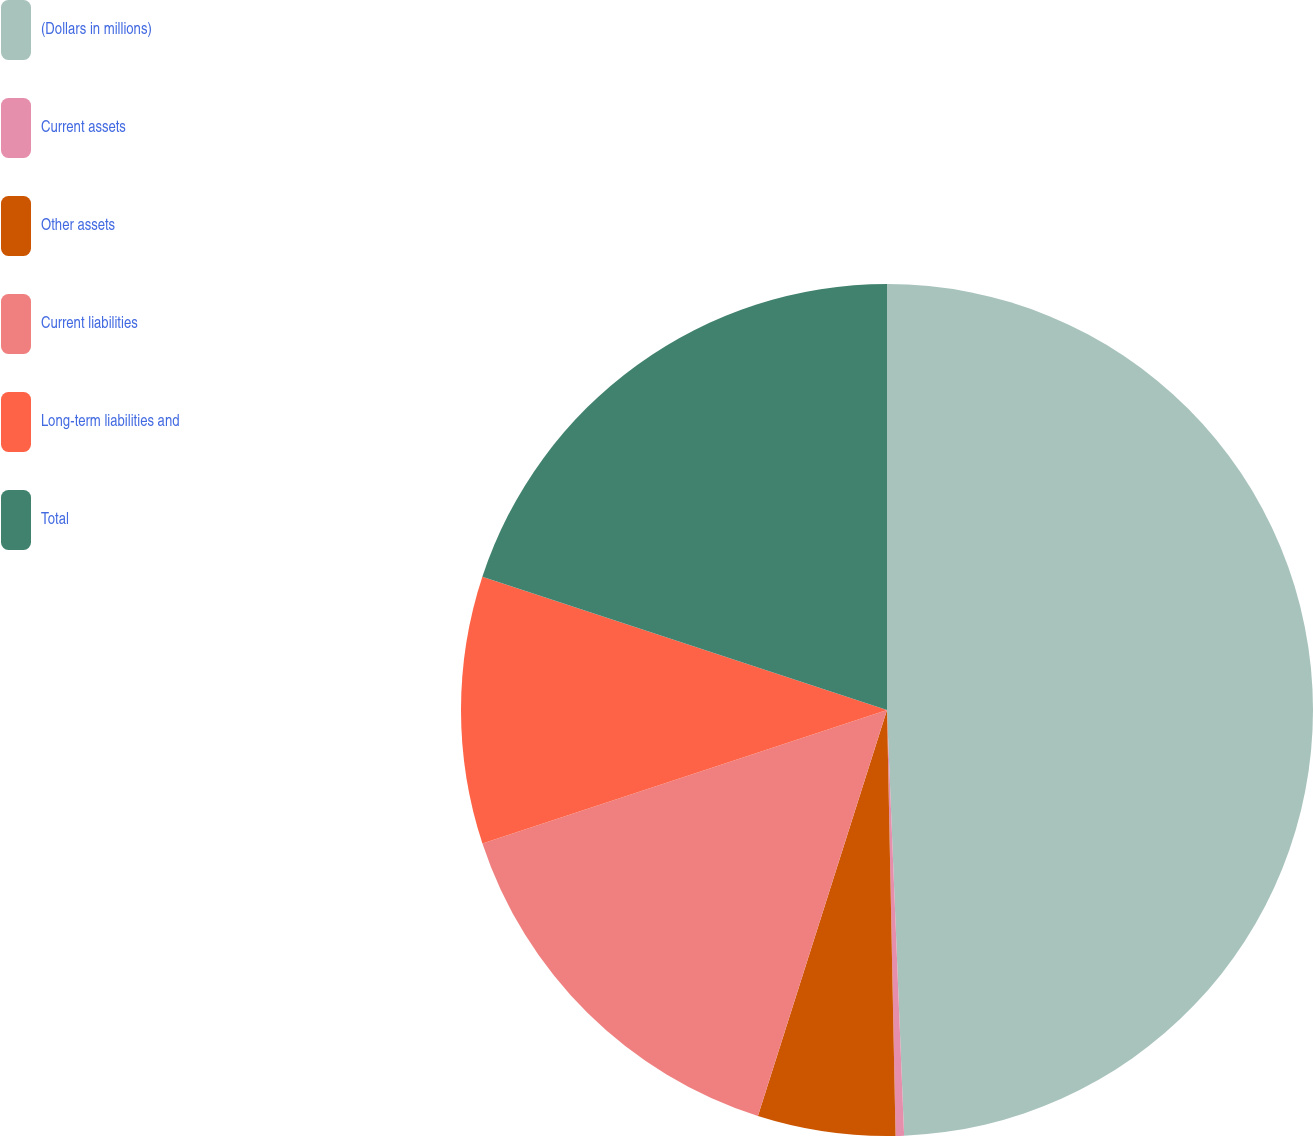Convert chart to OTSL. <chart><loc_0><loc_0><loc_500><loc_500><pie_chart><fcel>(Dollars in millions)<fcel>Current assets<fcel>Other assets<fcel>Current liabilities<fcel>Long-term liabilities and<fcel>Total<nl><fcel>49.36%<fcel>0.32%<fcel>5.22%<fcel>15.03%<fcel>10.13%<fcel>19.94%<nl></chart> 